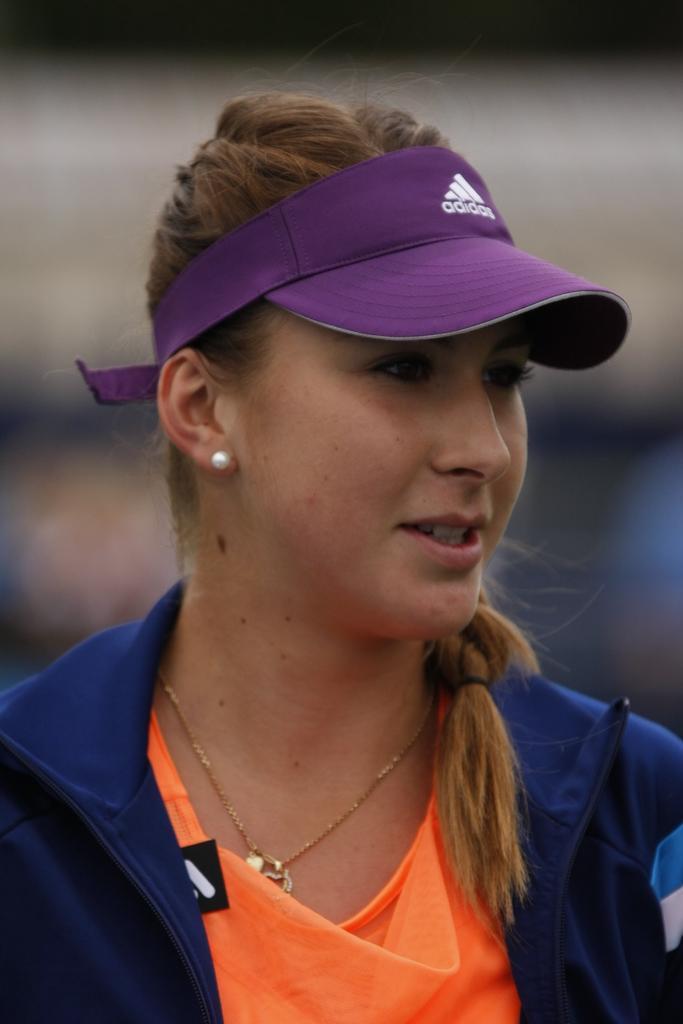Can you describe this image briefly? In this image I can see a woman wearing orange and blue colored dress and purple colored cap. I can see the blurry background. 